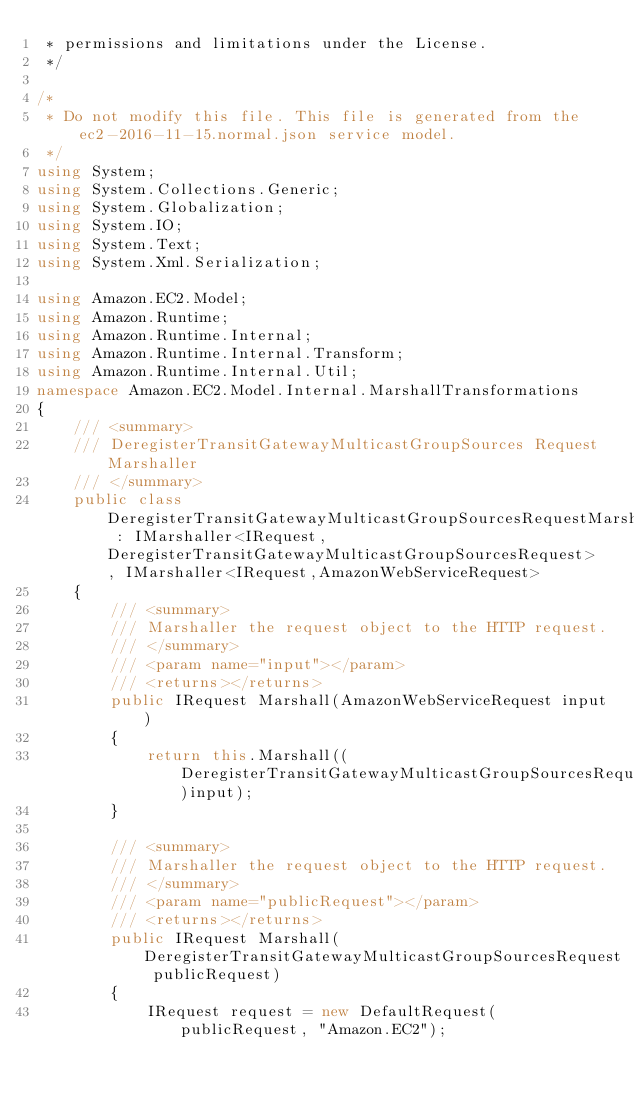Convert code to text. <code><loc_0><loc_0><loc_500><loc_500><_C#_> * permissions and limitations under the License.
 */

/*
 * Do not modify this file. This file is generated from the ec2-2016-11-15.normal.json service model.
 */
using System;
using System.Collections.Generic;
using System.Globalization;
using System.IO;
using System.Text;
using System.Xml.Serialization;

using Amazon.EC2.Model;
using Amazon.Runtime;
using Amazon.Runtime.Internal;
using Amazon.Runtime.Internal.Transform;
using Amazon.Runtime.Internal.Util;
namespace Amazon.EC2.Model.Internal.MarshallTransformations
{
    /// <summary>
    /// DeregisterTransitGatewayMulticastGroupSources Request Marshaller
    /// </summary>       
    public class DeregisterTransitGatewayMulticastGroupSourcesRequestMarshaller : IMarshaller<IRequest, DeregisterTransitGatewayMulticastGroupSourcesRequest> , IMarshaller<IRequest,AmazonWebServiceRequest>
    {
        /// <summary>
        /// Marshaller the request object to the HTTP request.
        /// </summary>  
        /// <param name="input"></param>
        /// <returns></returns>
        public IRequest Marshall(AmazonWebServiceRequest input)
        {
            return this.Marshall((DeregisterTransitGatewayMulticastGroupSourcesRequest)input);
        }
    
        /// <summary>
        /// Marshaller the request object to the HTTP request.
        /// </summary>  
        /// <param name="publicRequest"></param>
        /// <returns></returns>
        public IRequest Marshall(DeregisterTransitGatewayMulticastGroupSourcesRequest publicRequest)
        {
            IRequest request = new DefaultRequest(publicRequest, "Amazon.EC2");</code> 